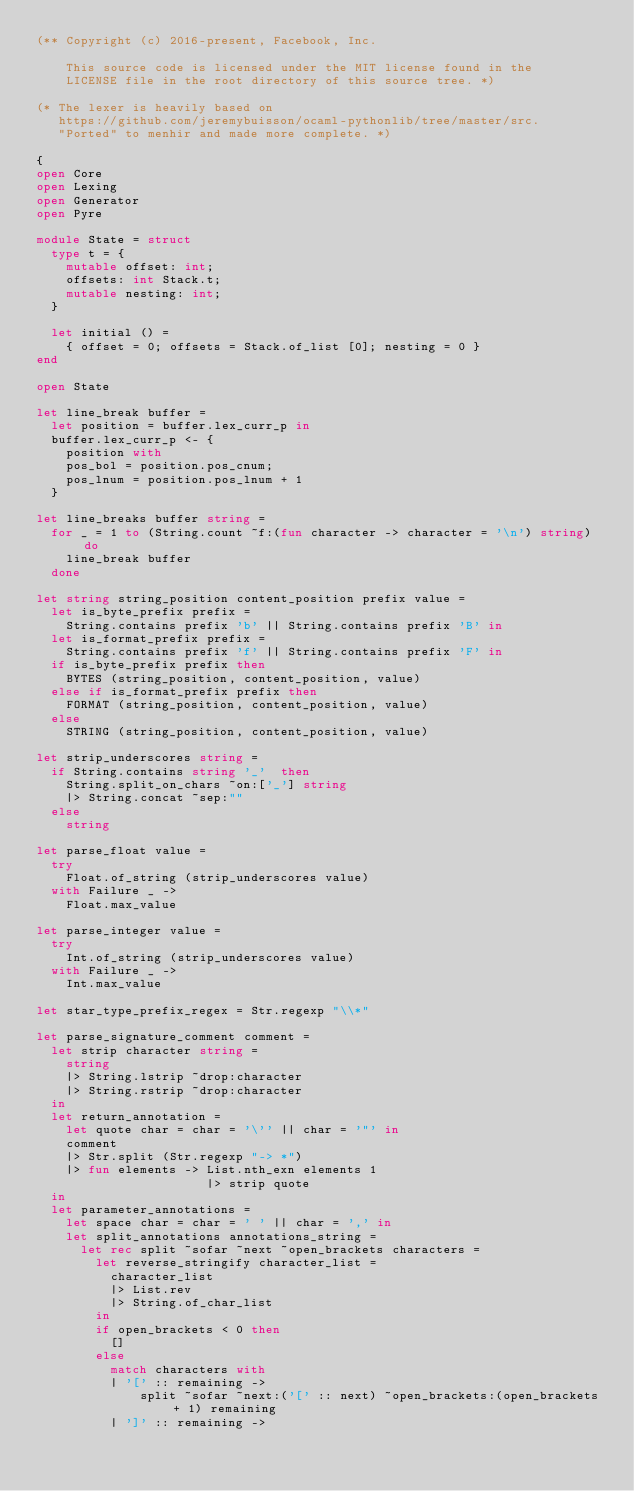<code> <loc_0><loc_0><loc_500><loc_500><_OCaml_>(** Copyright (c) 2016-present, Facebook, Inc.

    This source code is licensed under the MIT license found in the
    LICENSE file in the root directory of this source tree. *)

(* The lexer is heavily based on
   https://github.com/jeremybuisson/ocaml-pythonlib/tree/master/src.
   "Ported" to menhir and made more complete. *)

{
open Core
open Lexing
open Generator
open Pyre

module State = struct
  type t = {
    mutable offset: int;
    offsets: int Stack.t;
    mutable nesting: int;
  }

  let initial () =
    { offset = 0; offsets = Stack.of_list [0]; nesting = 0 }
end

open State

let line_break buffer =
  let position = buffer.lex_curr_p in
  buffer.lex_curr_p <- {
    position with
    pos_bol = position.pos_cnum;
    pos_lnum = position.pos_lnum + 1
  }

let line_breaks buffer string =
  for _ = 1 to (String.count ~f:(fun character -> character = '\n') string) do
    line_break buffer
  done

let string string_position content_position prefix value =
  let is_byte_prefix prefix =
    String.contains prefix 'b' || String.contains prefix 'B' in
  let is_format_prefix prefix =
    String.contains prefix 'f' || String.contains prefix 'F' in
  if is_byte_prefix prefix then
    BYTES (string_position, content_position, value)
  else if is_format_prefix prefix then
    FORMAT (string_position, content_position, value)
  else
    STRING (string_position, content_position, value)

let strip_underscores string =
  if String.contains string '_'  then
    String.split_on_chars ~on:['_'] string
    |> String.concat ~sep:""
  else
    string

let parse_float value =
  try
    Float.of_string (strip_underscores value)
  with Failure _ ->
    Float.max_value

let parse_integer value =
  try
    Int.of_string (strip_underscores value)
  with Failure _ ->
    Int.max_value

let star_type_prefix_regex = Str.regexp "\\*"

let parse_signature_comment comment =
  let strip character string =
    string
    |> String.lstrip ~drop:character
    |> String.rstrip ~drop:character
  in
  let return_annotation =
    let quote char = char = '\'' || char = '"' in
    comment
    |> Str.split (Str.regexp "-> *")
    |> fun elements -> List.nth_exn elements 1
                       |> strip quote
  in
  let parameter_annotations =
    let space char = char = ' ' || char = ',' in
    let split_annotations annotations_string =
      let rec split ~sofar ~next ~open_brackets characters =
        let reverse_stringify character_list =
          character_list
          |> List.rev
          |> String.of_char_list
        in
        if open_brackets < 0 then
          []
        else
          match characters with
          | '[' :: remaining ->
              split ~sofar ~next:('[' :: next) ~open_brackets:(open_brackets + 1) remaining
          | ']' :: remaining -></code> 